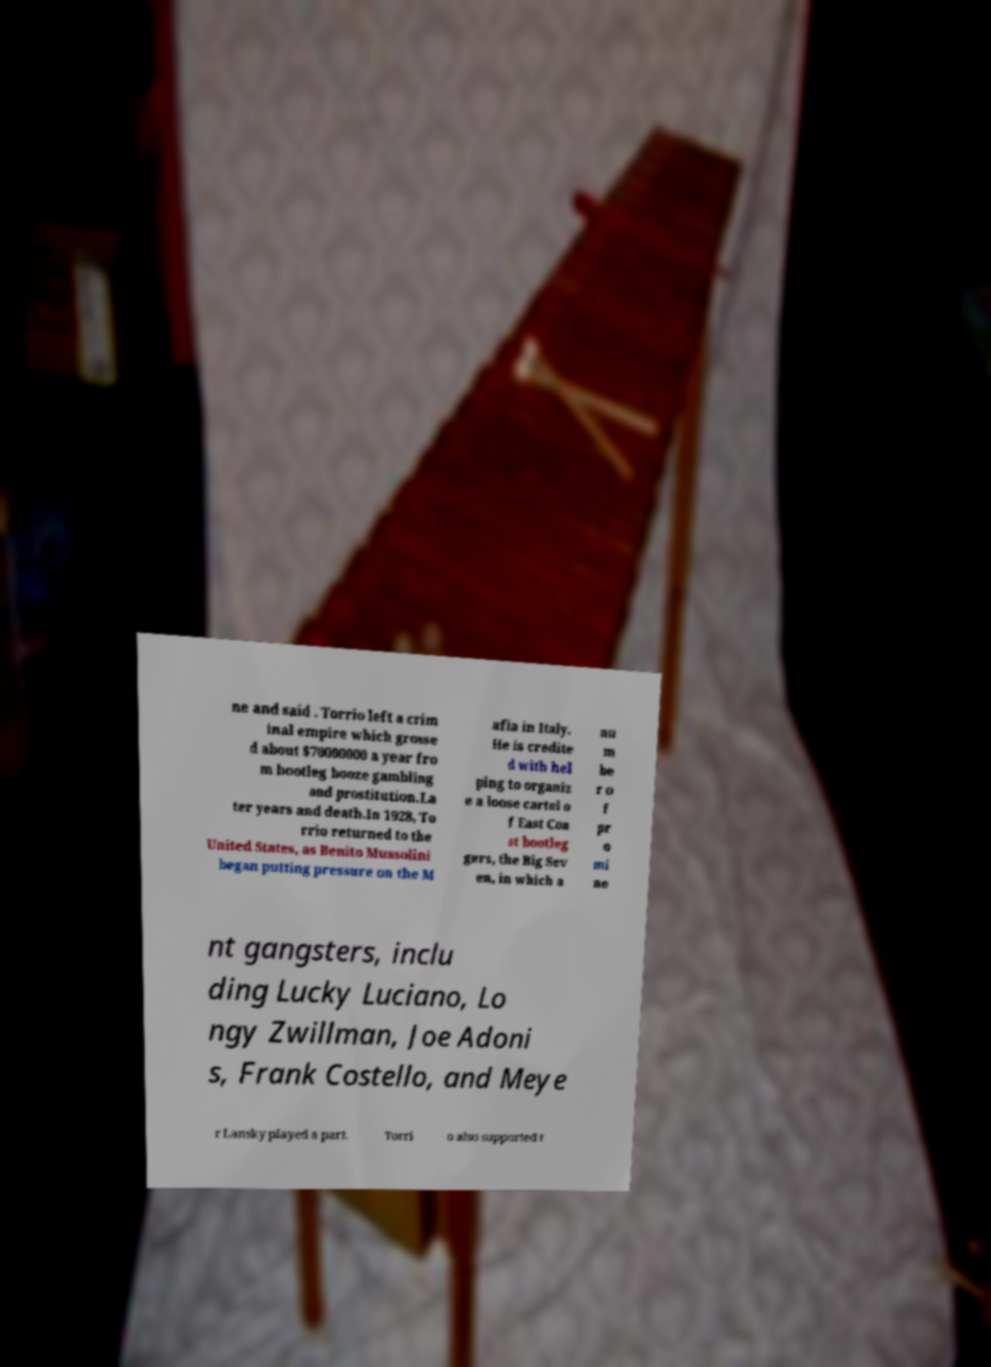Could you assist in decoding the text presented in this image and type it out clearly? ne and said . Torrio left a crim inal empire which grosse d about $70000000 a year fro m bootleg booze gambling and prostitution.La ter years and death.In 1928, To rrio returned to the United States, as Benito Mussolini began putting pressure on the M afia in Italy. He is credite d with hel ping to organiz e a loose cartel o f East Coa st bootleg gers, the Big Sev en, in which a nu m be r o f pr o mi ne nt gangsters, inclu ding Lucky Luciano, Lo ngy Zwillman, Joe Adoni s, Frank Costello, and Meye r Lansky played a part. Torri o also supported t 